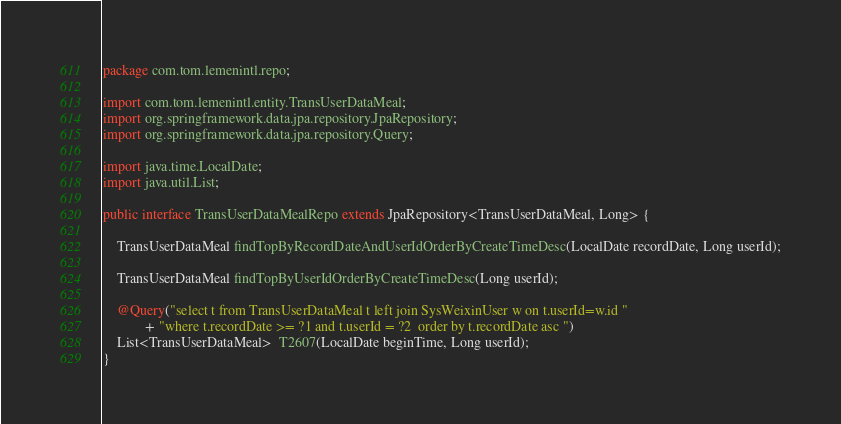Convert code to text. <code><loc_0><loc_0><loc_500><loc_500><_Java_>package com.tom.lemenintl.repo;

import com.tom.lemenintl.entity.TransUserDataMeal;
import org.springframework.data.jpa.repository.JpaRepository;
import org.springframework.data.jpa.repository.Query;

import java.time.LocalDate;
import java.util.List;

public interface TransUserDataMealRepo extends JpaRepository<TransUserDataMeal, Long> {

	TransUserDataMeal findTopByRecordDateAndUserIdOrderByCreateTimeDesc(LocalDate recordDate, Long userId);

	TransUserDataMeal findTopByUserIdOrderByCreateTimeDesc(Long userId);

	@Query("select t from TransUserDataMeal t left join SysWeixinUser w on t.userId=w.id "
	        + "where t.recordDate >= ?1 and t.userId = ?2  order by t.recordDate asc ")
	List<TransUserDataMeal>  T2607(LocalDate beginTime, Long userId);
}
</code> 